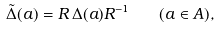<formula> <loc_0><loc_0><loc_500><loc_500>\tilde { \Delta } ( a ) = R \, \Delta ( a ) R ^ { - 1 } \quad ( a \in A ) ,</formula> 